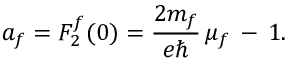Convert formula to latex. <formula><loc_0><loc_0><loc_500><loc_500>a _ { f } = F _ { 2 } ^ { f } ( 0 ) = \frac { 2 m _ { f } } { e } \, \mu _ { f } \, - \, 1 .</formula> 